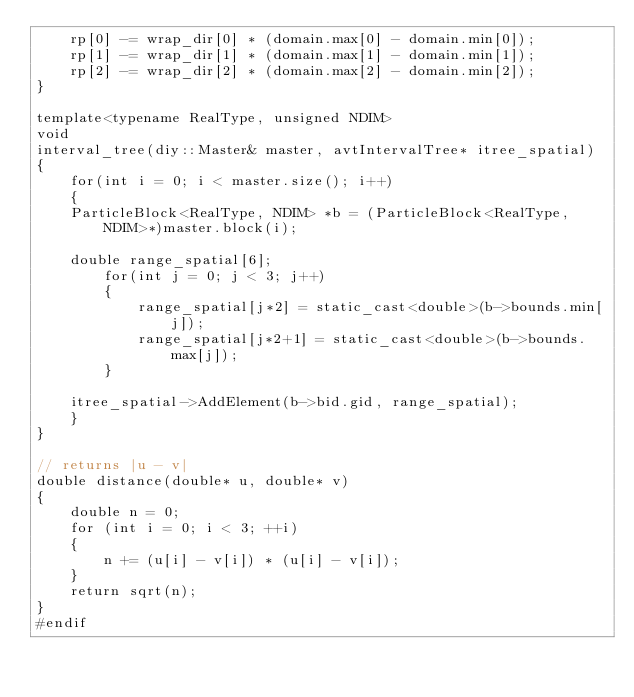<code> <loc_0><loc_0><loc_500><loc_500><_C++_>    rp[0] -= wrap_dir[0] * (domain.max[0] - domain.min[0]);
    rp[1] -= wrap_dir[1] * (domain.max[1] - domain.min[1]);
    rp[2] -= wrap_dir[2] * (domain.max[2] - domain.min[2]);
}

template<typename RealType, unsigned NDIM>
void 
interval_tree(diy::Master& master, avtIntervalTree* itree_spatial)
{
    for(int i = 0; i < master.size(); i++)
    {
	ParticleBlock<RealType, NDIM> *b = (ParticleBlock<RealType, NDIM>*)master.block(i);

	double range_spatial[6];
        for(int j = 0; j < 3; j++)
        {
            range_spatial[j*2] = static_cast<double>(b->bounds.min[j]); 
            range_spatial[j*2+1] = static_cast<double>(b->bounds.max[j]); 
        }

	itree_spatial->AddElement(b->bid.gid, range_spatial);
    }
}

// returns |u - v|
double distance(double* u, double* v)
{
    double n = 0;
    for (int i = 0; i < 3; ++i)
    {
        n += (u[i] - v[i]) * (u[i] - v[i]);
    }
    return sqrt(n);
}
#endif



</code> 